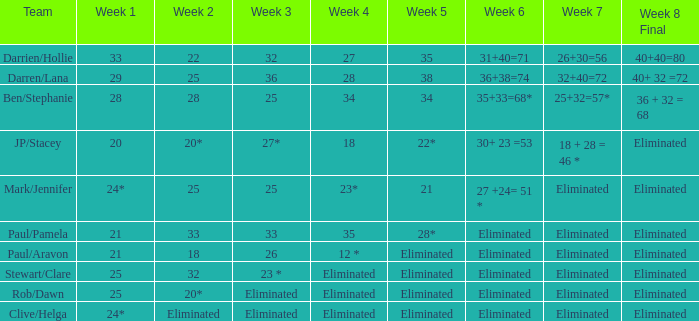Can you specify the 3rd week in a 36-week timeframe? 29.0. 